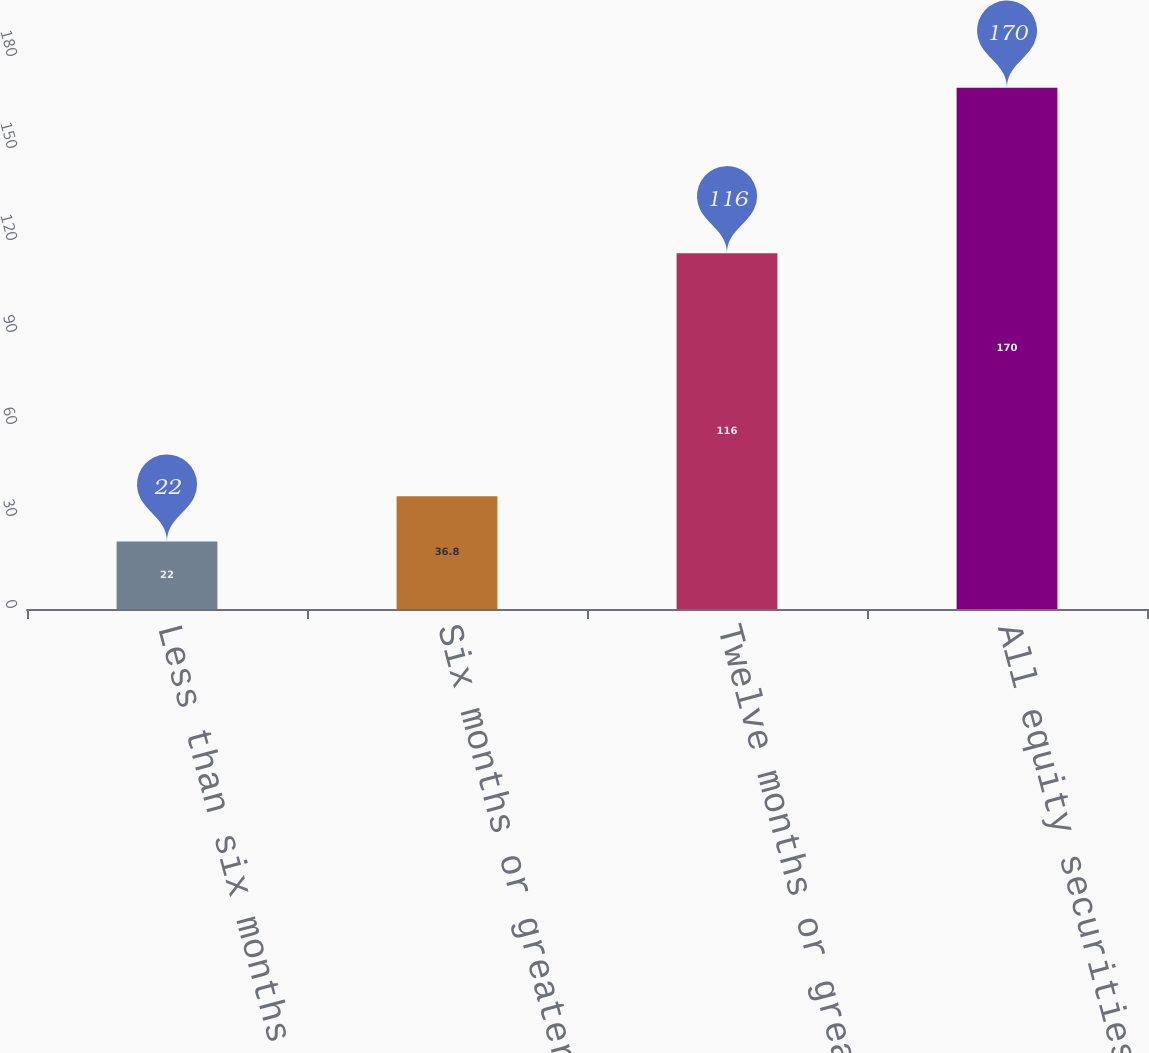<chart> <loc_0><loc_0><loc_500><loc_500><bar_chart><fcel>Less than six months<fcel>Six months or greater but less<fcel>Twelve months or greater<fcel>All equity securities with a<nl><fcel>22<fcel>36.8<fcel>116<fcel>170<nl></chart> 